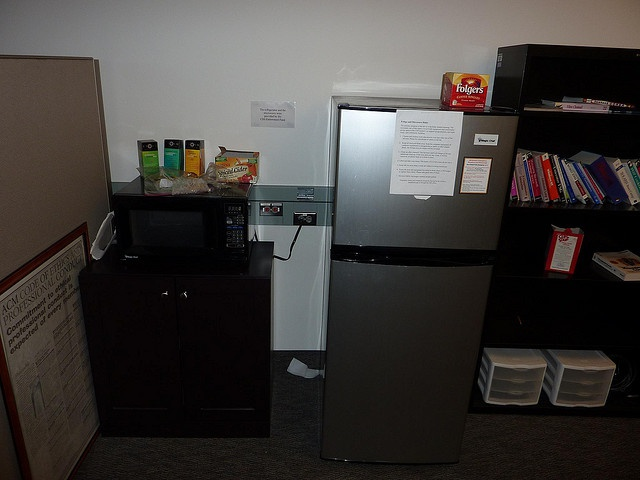Describe the objects in this image and their specific colors. I can see refrigerator in gray, black, darkgray, and lightgray tones, oven in gray, black, purple, and darkgray tones, microwave in gray, black, and navy tones, book in gray, black, maroon, and navy tones, and book in gray, black, and maroon tones in this image. 